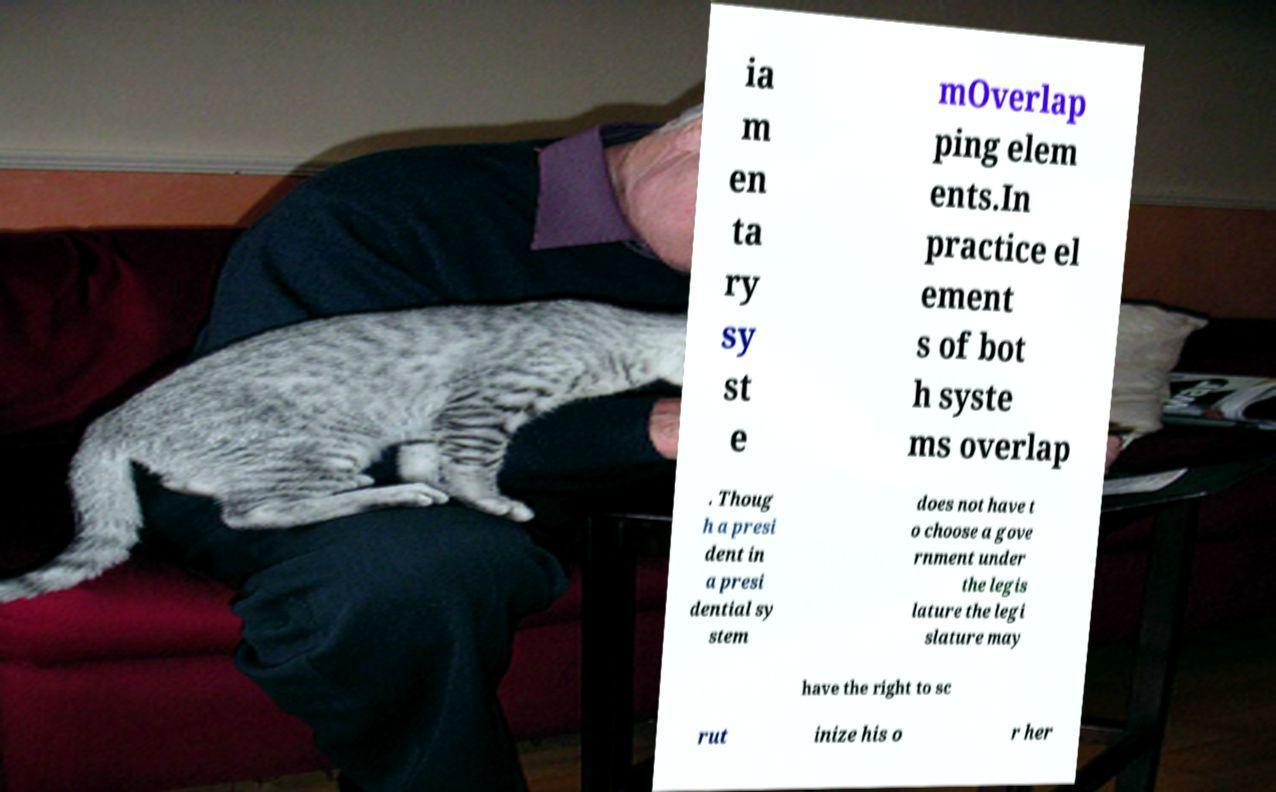Can you accurately transcribe the text from the provided image for me? ia m en ta ry sy st e mOverlap ping elem ents.In practice el ement s of bot h syste ms overlap . Thoug h a presi dent in a presi dential sy stem does not have t o choose a gove rnment under the legis lature the legi slature may have the right to sc rut inize his o r her 